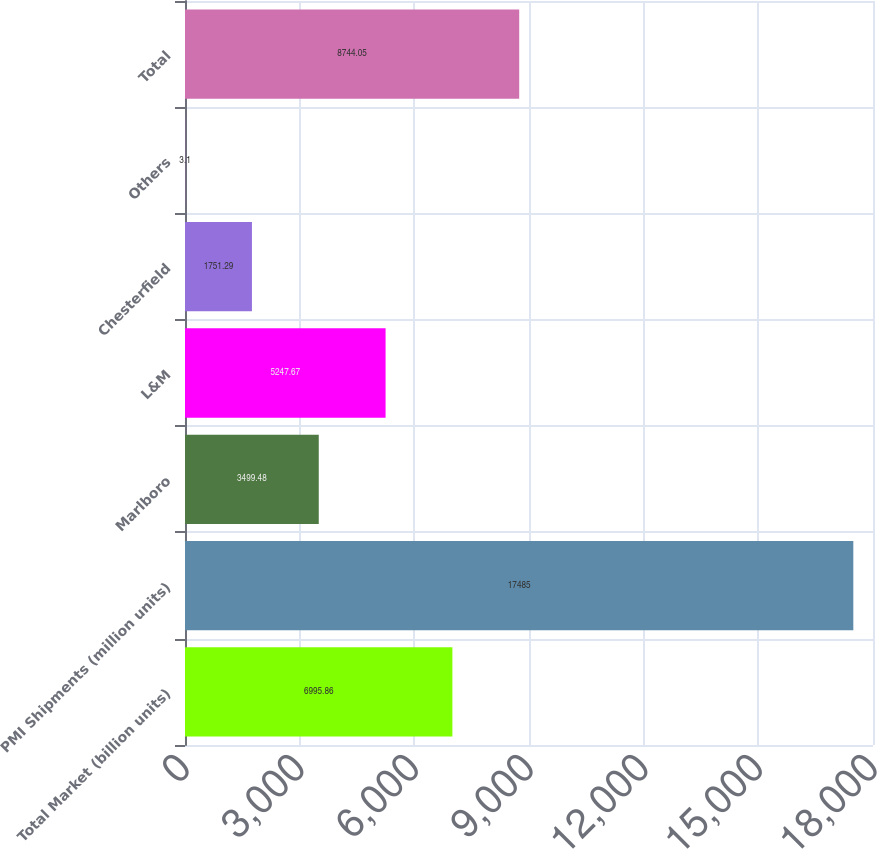Convert chart. <chart><loc_0><loc_0><loc_500><loc_500><bar_chart><fcel>Total Market (billion units)<fcel>PMI Shipments (million units)<fcel>Marlboro<fcel>L&M<fcel>Chesterfield<fcel>Others<fcel>Total<nl><fcel>6995.86<fcel>17485<fcel>3499.48<fcel>5247.67<fcel>1751.29<fcel>3.1<fcel>8744.05<nl></chart> 